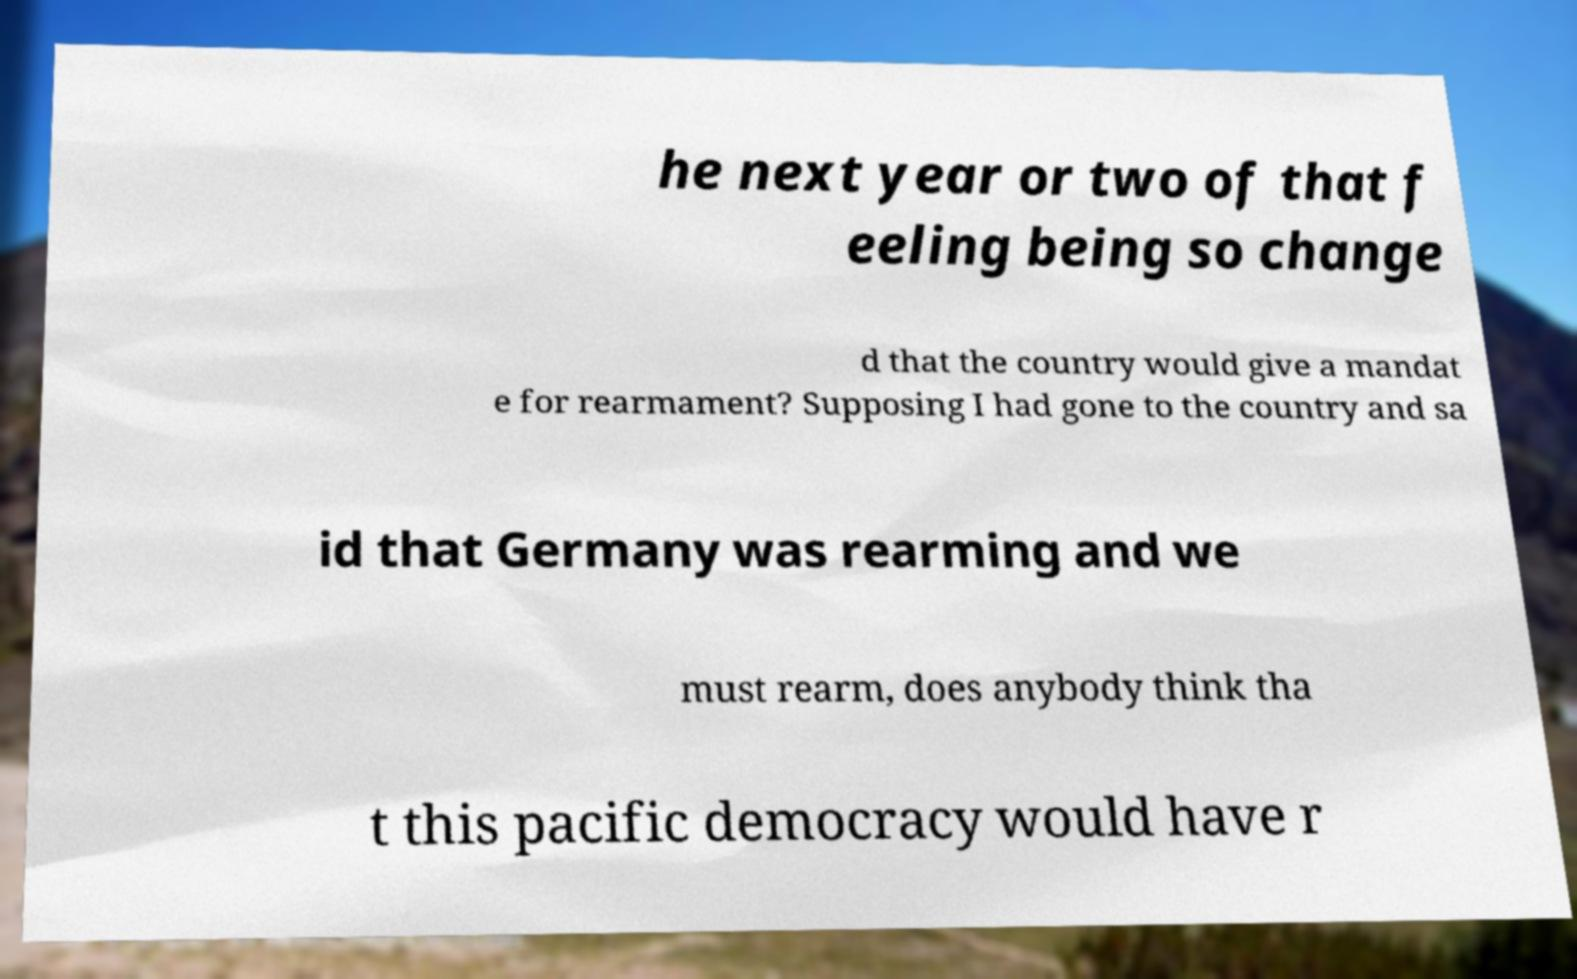For documentation purposes, I need the text within this image transcribed. Could you provide that? he next year or two of that f eeling being so change d that the country would give a mandat e for rearmament? Supposing I had gone to the country and sa id that Germany was rearming and we must rearm, does anybody think tha t this pacific democracy would have r 